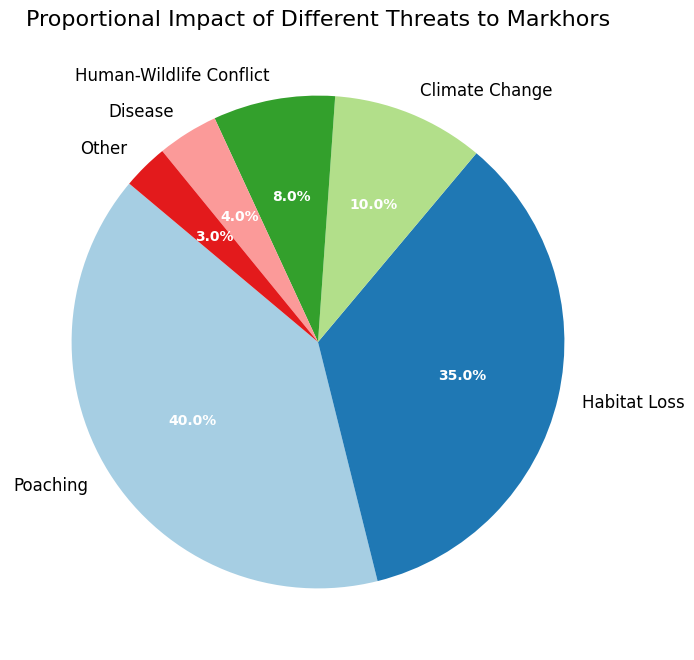What is the category with the highest impact percentage? The largest slice in the pie chart represents the category with the highest impact percentage. By observing the chart, we can see that the "Poaching" slice is the largest.
Answer: Poaching Which category has a lower impact percentage than Climate Change but higher than Disease? We need to identify the categories with impact percentages immediately lower than 10% (Climate Change) and higher than 4% (Disease). From the chart, "Human-Wildlife Conflict" fits this condition with 8%.
Answer: Human-Wildlife Conflict What is the combined impact percentage of Poaching and Habitat Loss? To find the combined impact, sum the percentages of Poaching (40%) and Habitat Loss (35%). 40 + 35 = 75
Answer: 75 How many categories have an impact percentage above the average impact percentage? First, compute the average impact percentage. Sum all the percentages (40 + 35 + 10 + 8 + 4 + 3 = 100) and divide by the number of categories (6). The average is 100/6 ≈ 16.67. Categories above this average are Poaching (40%) and Habitat Loss (35%).
Answer: 2 Between Human-Wildlife Conflict and Disease, which has a lesser impact? Compare the impact percentages of Human-Wildlife Conflict (8%) and Disease (4%). Disease has a lesser impact.
Answer: Disease What is the impact percentage difference between Climate Change and Other threats? Subtract the impact percentage of Other (3%) from Climate Change (10%). 10 - 3 = 7
Answer: 7 If the threats were grouped into two categories, one combining Poaching and Habitat Loss and the other combining all remaining threats, which group would have a higher percentage? Sum the percentages for Poaching (40%) and Habitat Loss (35%). 40 + 35 = 75. Sum the remaining threats (10 + 8 + 4 + 3 = 25). The combined Poaching and Habitat Loss group has a higher percentage (75).
Answer: Poaching and Habitat Loss Which threat category has the smallest visual representation in the pie chart? The smallest slice in the pie chart corresponds to the category with the lowest impact percentage, which is "Other" at 3%.
Answer: Other Is the proportion of Climate Change threats greater or less than one-third of Poaching threats? One-third of the Poaching percentage is 40/3 ≈ 13.33%. Climate Change impact is 10%. Therefore, the impact of Climate Change is less than one-third of Poaching.
Answer: Less If you were to combine Disease and Other threats into a single category, what would be their combined impact percentage? Add the impact percentages of Disease (4%) and Other (3%). 4 + 3 = 7
Answer: 7 